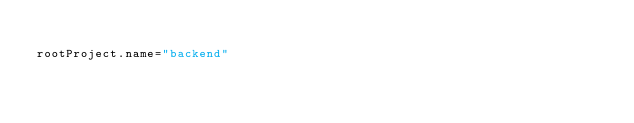<code> <loc_0><loc_0><loc_500><loc_500><_Kotlin_>
rootProject.name="backend"
</code> 